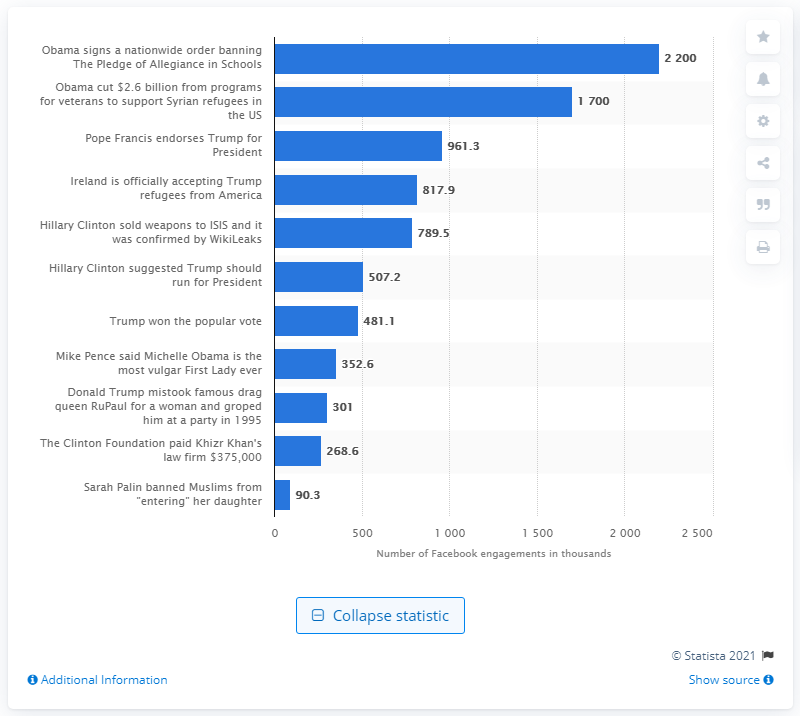Which fake news story was the second most shared on Facebook? The second most shared fake news story is the one that claims 'Pope Francis endorses Trump for President,' with roughly 961,300 shares on Facebook. 